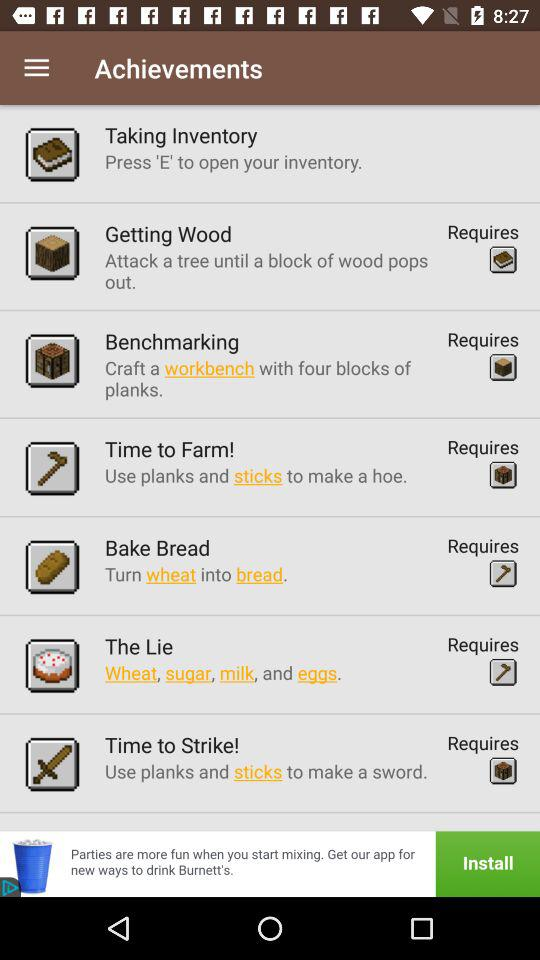What is the application name?
When the provided information is insufficient, respond with <no answer>. <no answer> 